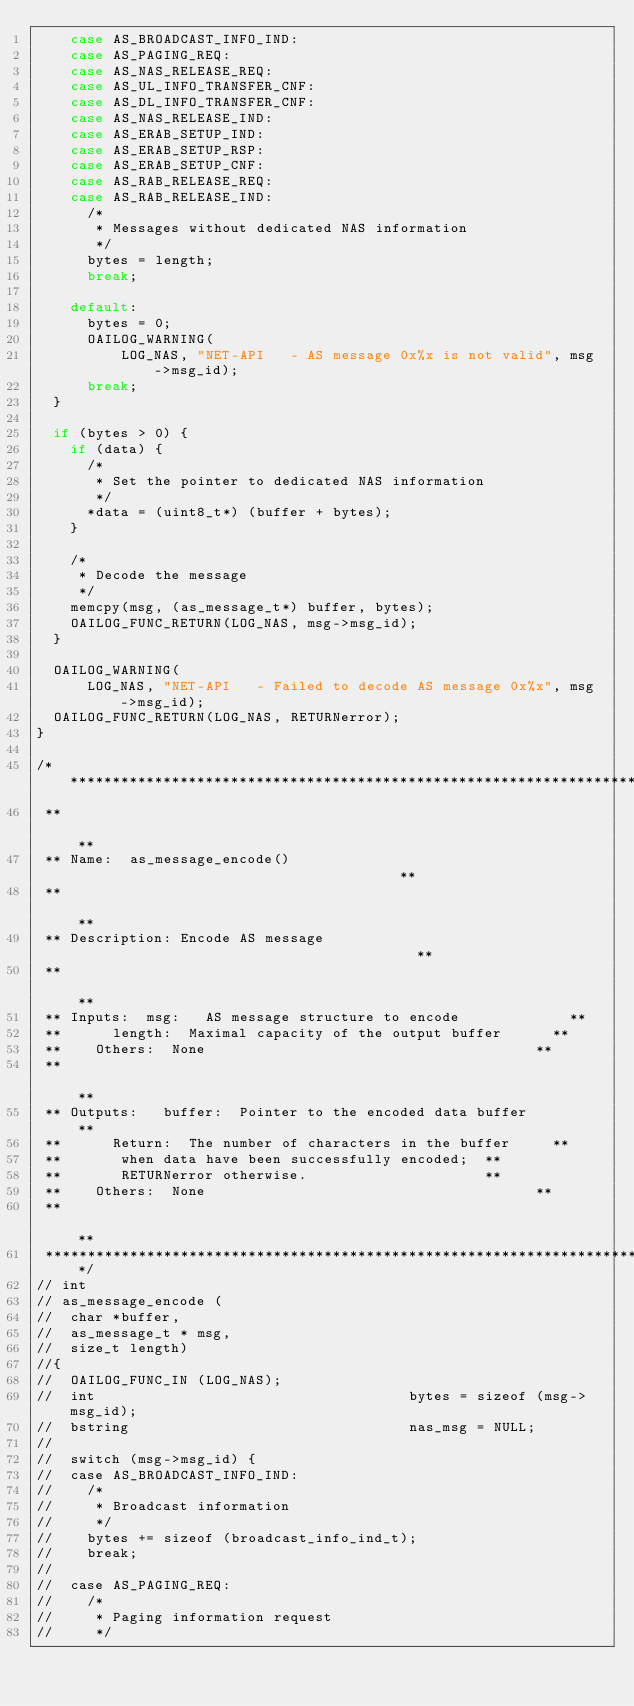Convert code to text. <code><loc_0><loc_0><loc_500><loc_500><_C_>    case AS_BROADCAST_INFO_IND:
    case AS_PAGING_REQ:
    case AS_NAS_RELEASE_REQ:
    case AS_UL_INFO_TRANSFER_CNF:
    case AS_DL_INFO_TRANSFER_CNF:
    case AS_NAS_RELEASE_IND:
    case AS_ERAB_SETUP_IND:
    case AS_ERAB_SETUP_RSP:
    case AS_ERAB_SETUP_CNF:
    case AS_RAB_RELEASE_REQ:
    case AS_RAB_RELEASE_IND:
      /*
       * Messages without dedicated NAS information
       */
      bytes = length;
      break;

    default:
      bytes = 0;
      OAILOG_WARNING(
          LOG_NAS, "NET-API   - AS message 0x%x is not valid", msg->msg_id);
      break;
  }

  if (bytes > 0) {
    if (data) {
      /*
       * Set the pointer to dedicated NAS information
       */
      *data = (uint8_t*) (buffer + bytes);
    }

    /*
     * Decode the message
     */
    memcpy(msg, (as_message_t*) buffer, bytes);
    OAILOG_FUNC_RETURN(LOG_NAS, msg->msg_id);
  }

  OAILOG_WARNING(
      LOG_NAS, "NET-API   - Failed to decode AS message 0x%x", msg->msg_id);
  OAILOG_FUNC_RETURN(LOG_NAS, RETURNerror);
}

/****************************************************************************
 **                                                                        **
 ** Name:  as_message_encode()                                       **
 **                                                                        **
 ** Description: Encode AS message                                         **
 **                                                                        **
 ** Inputs:  msg:   AS message structure to encode             **
 **      length:  Maximal capacity of the output buffer      **
 **    Others:  None                                       **
 **                                                                        **
 ** Outputs:   buffer:  Pointer to the encoded data buffer         **
 **      Return:  The number of characters in the buffer     **
 **       when data have been successfully encoded;  **
 **       RETURNerror otherwise.                     **
 **    Others:  None                                       **
 **                                                                        **
 ***************************************************************************/
// int
// as_message_encode (
//  char *buffer,
//  as_message_t * msg,
//  size_t length)
//{
//  OAILOG_FUNC_IN (LOG_NAS);
//  int                                     bytes = sizeof (msg->msg_id);
//  bstring                                 nas_msg = NULL;
//
//  switch (msg->msg_id) {
//  case AS_BROADCAST_INFO_IND:
//    /*
//     * Broadcast information
//     */
//    bytes += sizeof (broadcast_info_ind_t);
//    break;
//
//  case AS_PAGING_REQ:
//    /*
//     * Paging information request
//     */</code> 